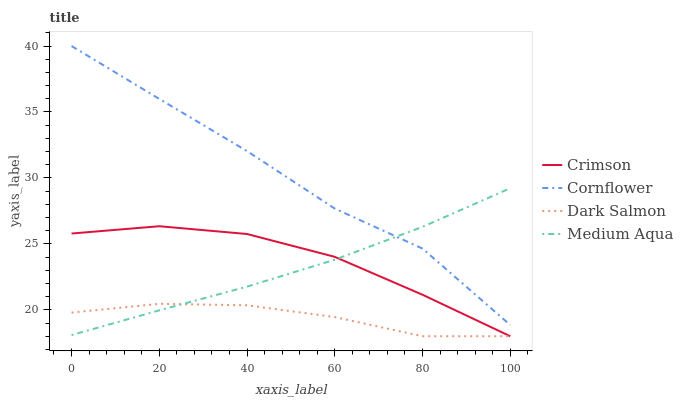Does Dark Salmon have the minimum area under the curve?
Answer yes or no. Yes. Does Cornflower have the maximum area under the curve?
Answer yes or no. Yes. Does Medium Aqua have the minimum area under the curve?
Answer yes or no. No. Does Medium Aqua have the maximum area under the curve?
Answer yes or no. No. Is Medium Aqua the smoothest?
Answer yes or no. Yes. Is Cornflower the roughest?
Answer yes or no. Yes. Is Cornflower the smoothest?
Answer yes or no. No. Is Medium Aqua the roughest?
Answer yes or no. No. Does Crimson have the lowest value?
Answer yes or no. Yes. Does Medium Aqua have the lowest value?
Answer yes or no. No. Does Cornflower have the highest value?
Answer yes or no. Yes. Does Medium Aqua have the highest value?
Answer yes or no. No. Is Dark Salmon less than Cornflower?
Answer yes or no. Yes. Is Cornflower greater than Dark Salmon?
Answer yes or no. Yes. Does Medium Aqua intersect Crimson?
Answer yes or no. Yes. Is Medium Aqua less than Crimson?
Answer yes or no. No. Is Medium Aqua greater than Crimson?
Answer yes or no. No. Does Dark Salmon intersect Cornflower?
Answer yes or no. No. 